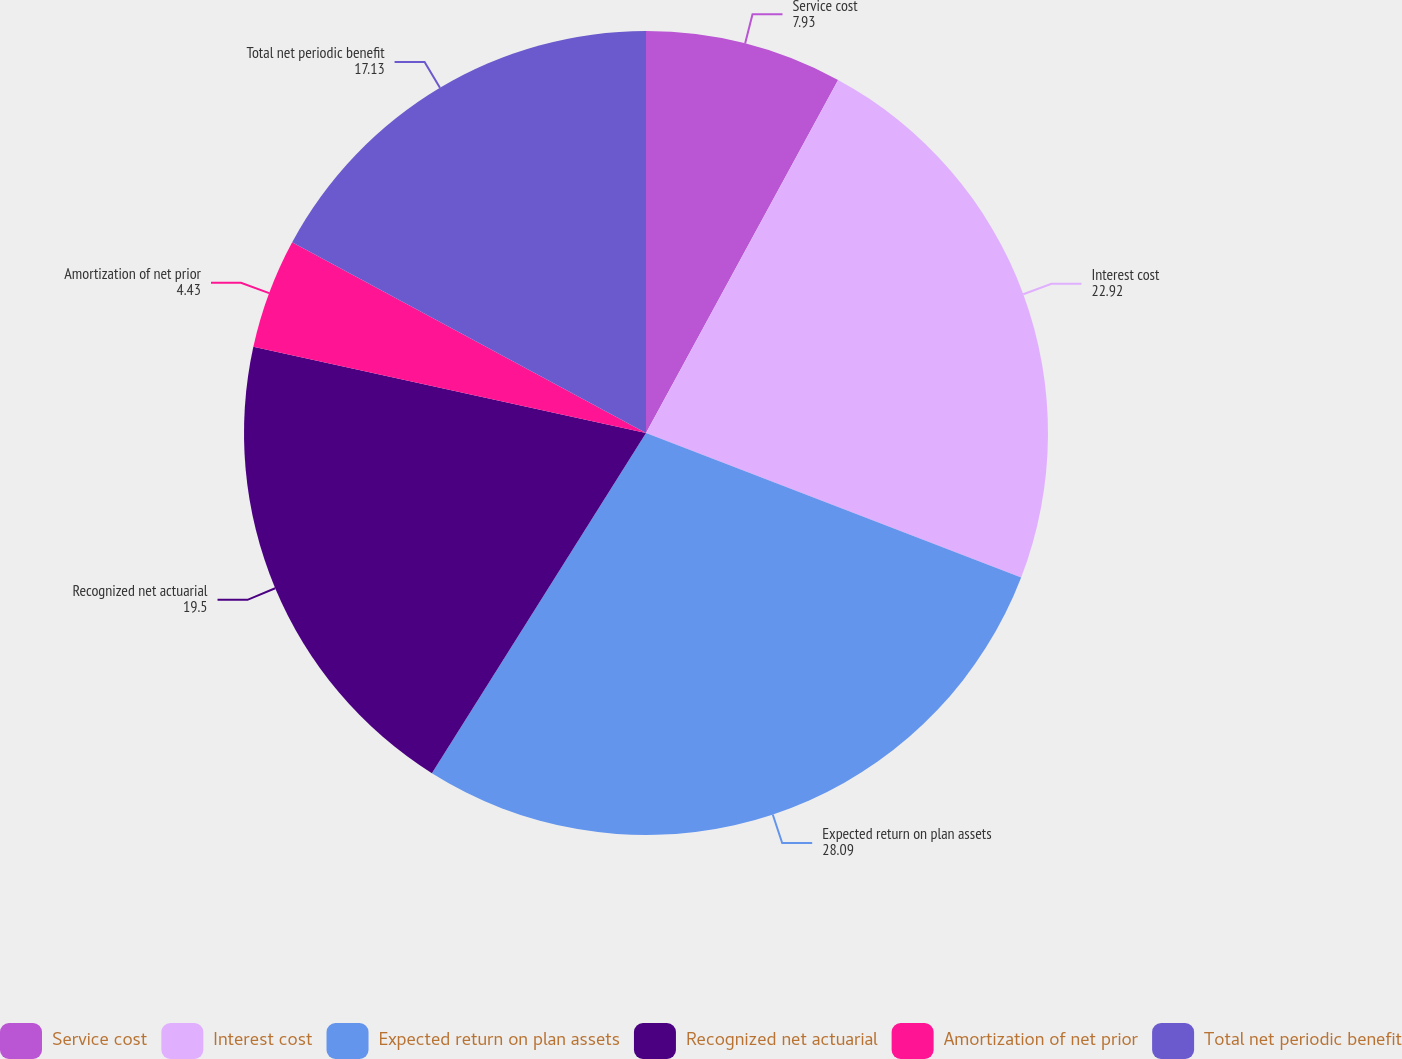Convert chart to OTSL. <chart><loc_0><loc_0><loc_500><loc_500><pie_chart><fcel>Service cost<fcel>Interest cost<fcel>Expected return on plan assets<fcel>Recognized net actuarial<fcel>Amortization of net prior<fcel>Total net periodic benefit<nl><fcel>7.93%<fcel>22.92%<fcel>28.09%<fcel>19.5%<fcel>4.43%<fcel>17.13%<nl></chart> 